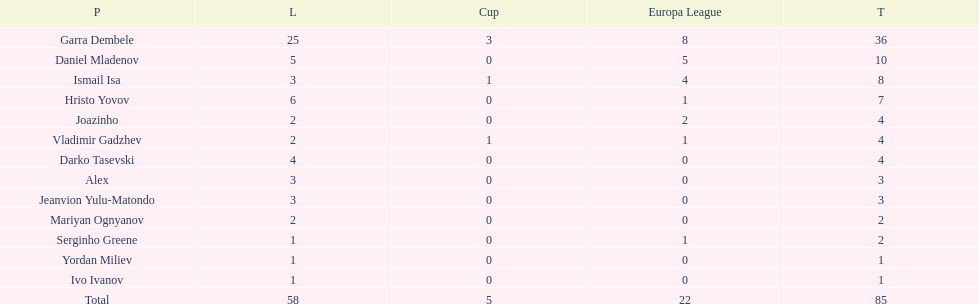Which players have at least 4 in the europa league? Garra Dembele, Daniel Mladenov, Ismail Isa. 